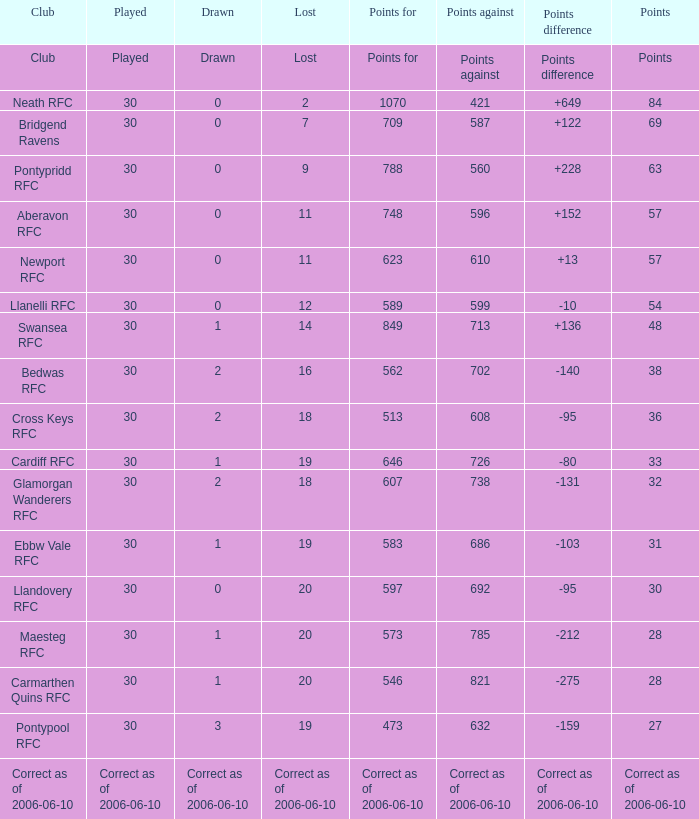What is represented when the "points against" figure is 686? 1.0. 